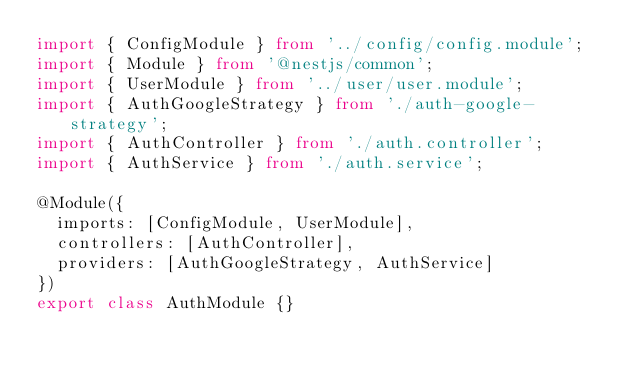Convert code to text. <code><loc_0><loc_0><loc_500><loc_500><_TypeScript_>import { ConfigModule } from '../config/config.module';
import { Module } from '@nestjs/common';
import { UserModule } from '../user/user.module';
import { AuthGoogleStrategy } from './auth-google-strategy';
import { AuthController } from './auth.controller';
import { AuthService } from './auth.service';

@Module({
  imports: [ConfigModule, UserModule],
  controllers: [AuthController],
  providers: [AuthGoogleStrategy, AuthService]
})
export class AuthModule {}
</code> 